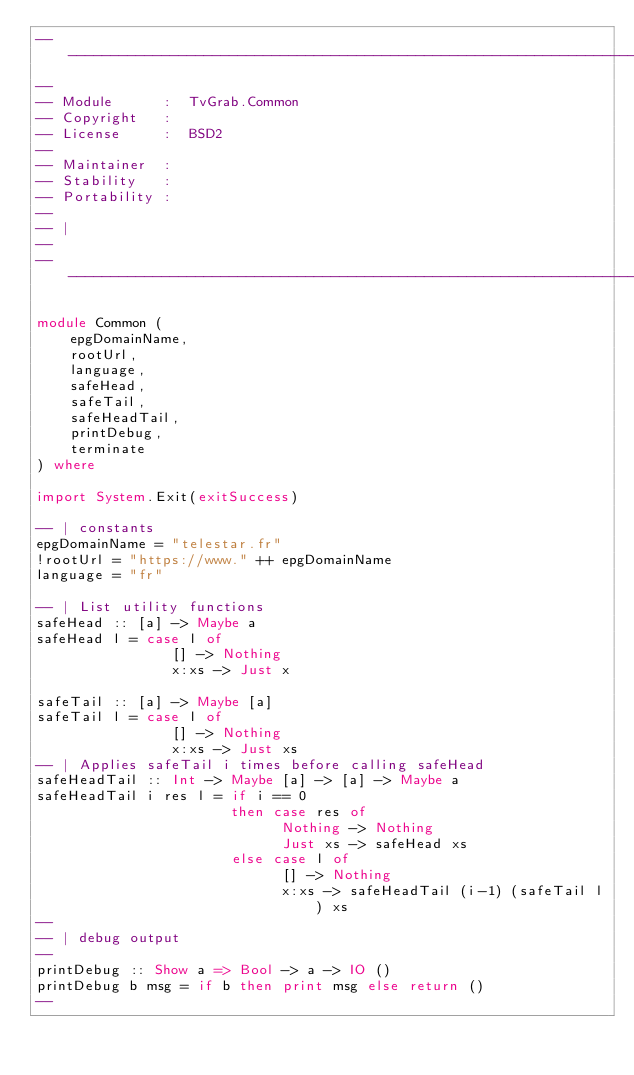<code> <loc_0><loc_0><loc_500><loc_500><_Haskell_>-----------------------------------------------------------------------------
--
-- Module      :  TvGrab.Common
-- Copyright   :
-- License     :  BSD2
--
-- Maintainer  :
-- Stability   :
-- Portability :
--
-- |
--
-----------------------------------------------------------------------------

module Common (
    epgDomainName,
    rootUrl,
    language,
    safeHead,
    safeTail,
    safeHeadTail,
    printDebug,
    terminate
) where

import System.Exit(exitSuccess)

-- | constants
epgDomainName = "telestar.fr"
!rootUrl = "https://www." ++ epgDomainName
language = "fr"

-- | List utility functions
safeHead :: [a] -> Maybe a
safeHead l = case l of
                [] -> Nothing
                x:xs -> Just x

safeTail :: [a] -> Maybe [a]
safeTail l = case l of
                [] -> Nothing
                x:xs -> Just xs
-- | Applies safeTail i times before calling safeHead
safeHeadTail :: Int -> Maybe [a] -> [a] -> Maybe a
safeHeadTail i res l = if i == 0
                       then case res of
                             Nothing -> Nothing
                             Just xs -> safeHead xs
                       else case l of
                             [] -> Nothing
                             x:xs -> safeHeadTail (i-1) (safeTail l) xs
--
-- | debug output
--
printDebug :: Show a => Bool -> a -> IO ()
printDebug b msg = if b then print msg else return ()
--</code> 